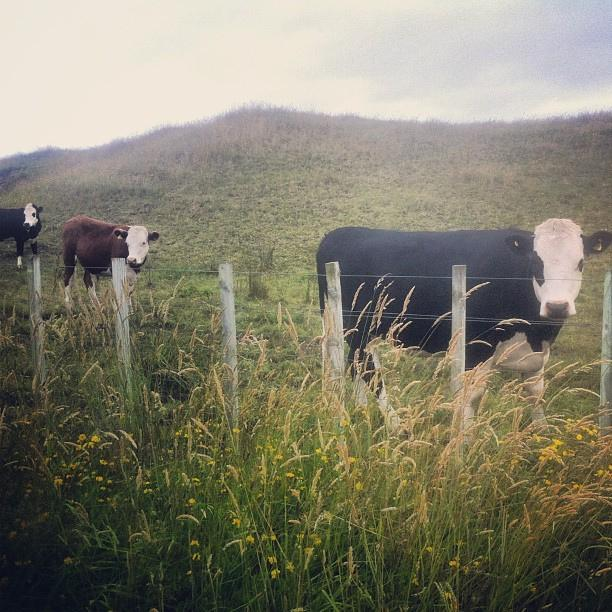What color is the cow in between the two milkcows? Please explain your reasoning. brown. The cow in between the milkcows is brown. 